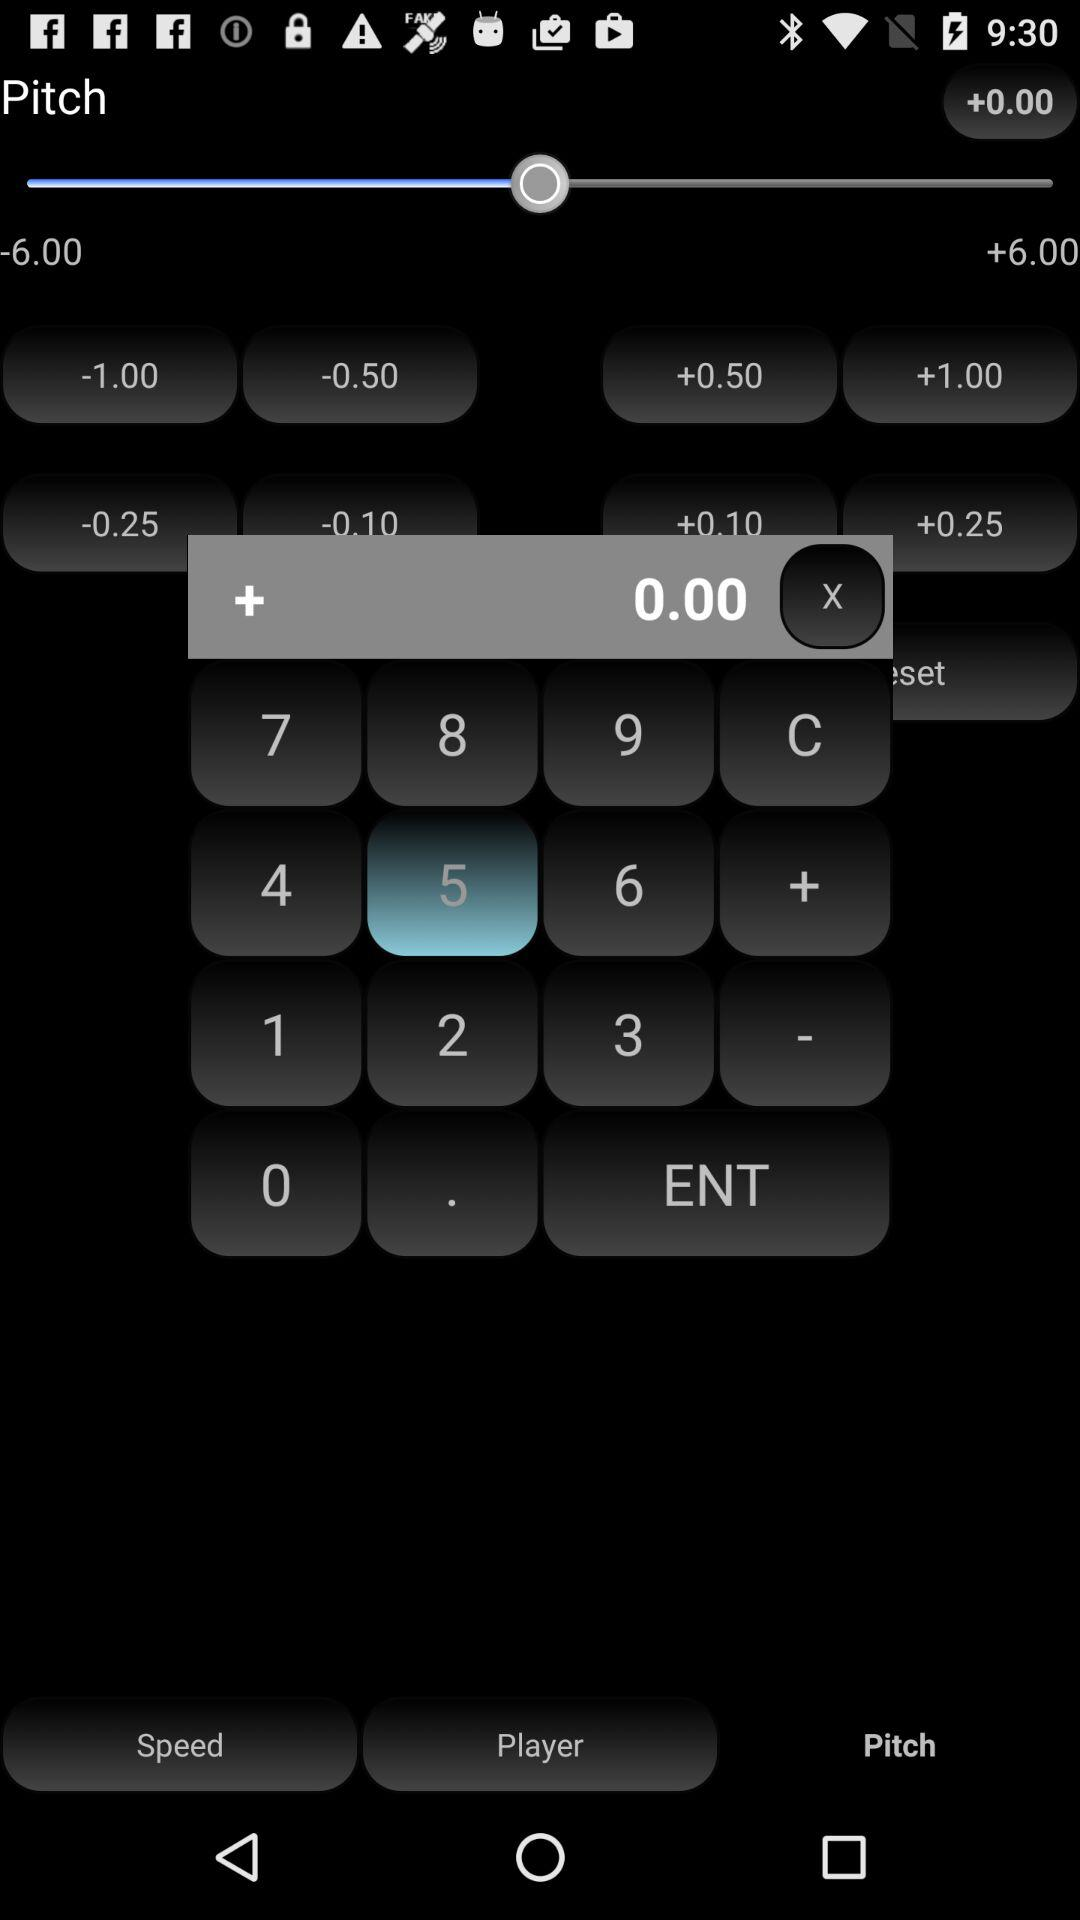Which digit is highlighted? The highlighted digit is 5. 